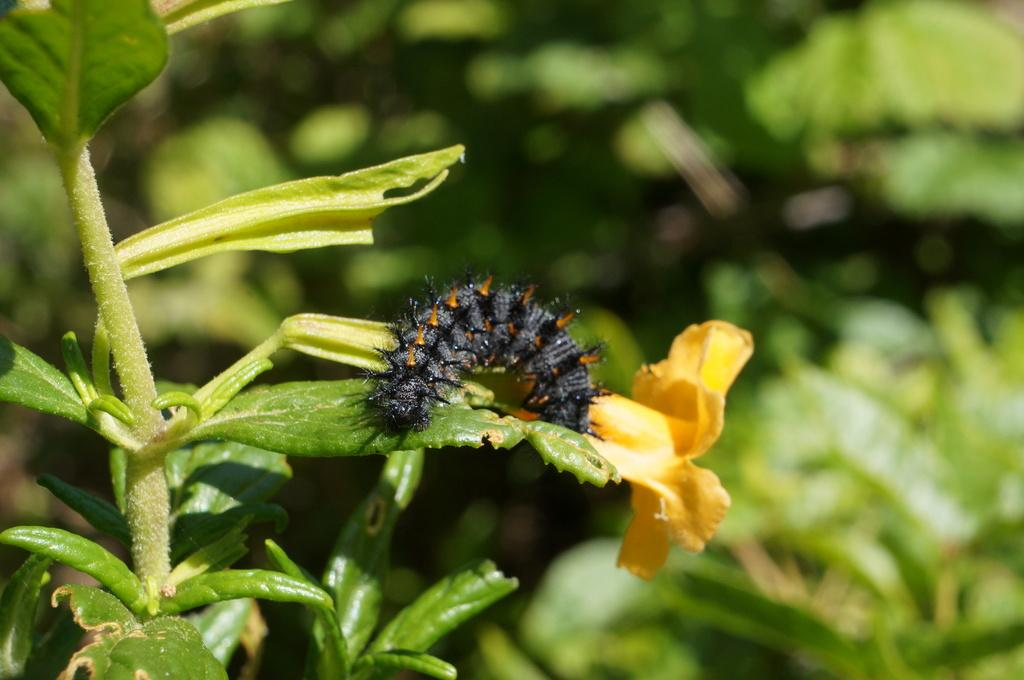What is on the leaf in the image? There is an insect on a leaf in the image. What type of flower can be seen in the image? There is a yellow flower in the image. What can be seen in the background of the image? There are plants in the background of the image. What color are the plants in the background? The plants in the background are green. How many tickets can be seen on the leaf with the insect? There are no tickets present in the image; it features an insect on a leaf and a yellow flower. 